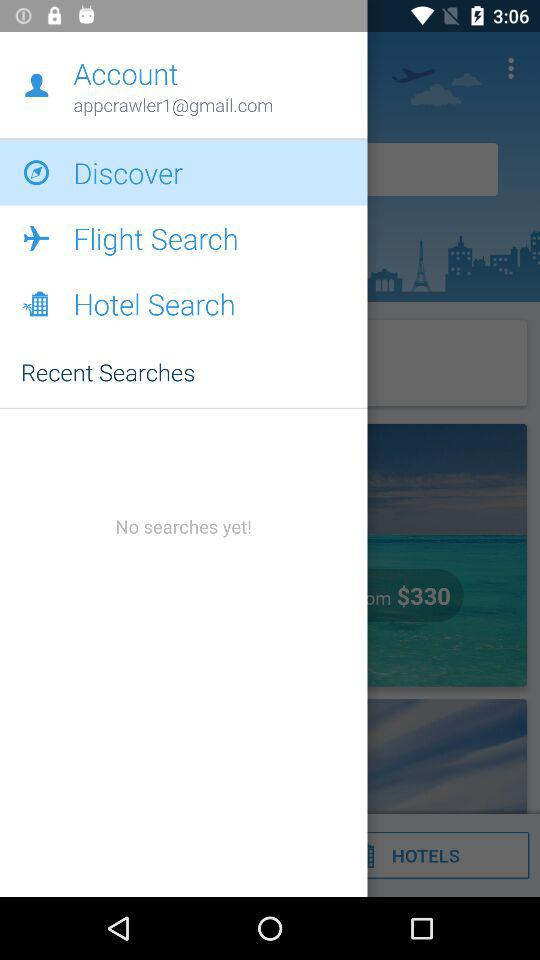Which option is selected? The selected option is "Discover". 